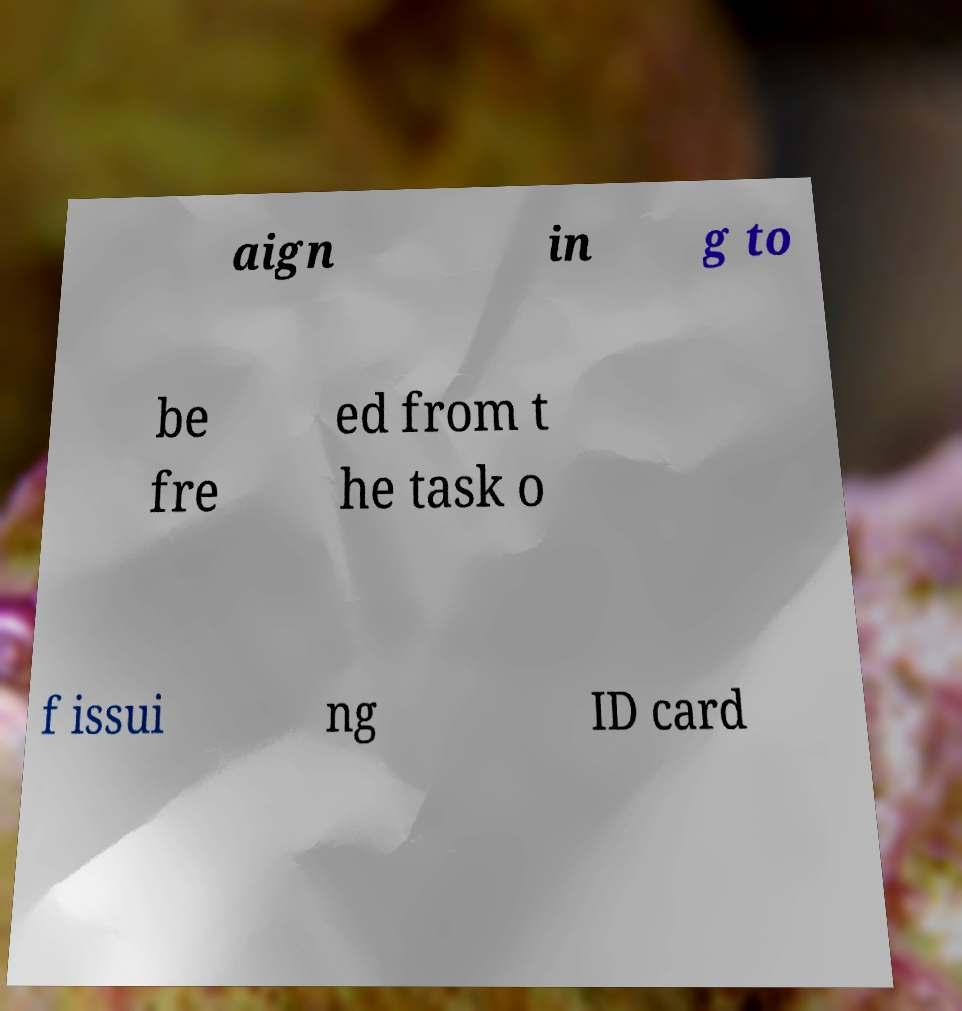Can you read and provide the text displayed in the image?This photo seems to have some interesting text. Can you extract and type it out for me? aign in g to be fre ed from t he task o f issui ng ID card 